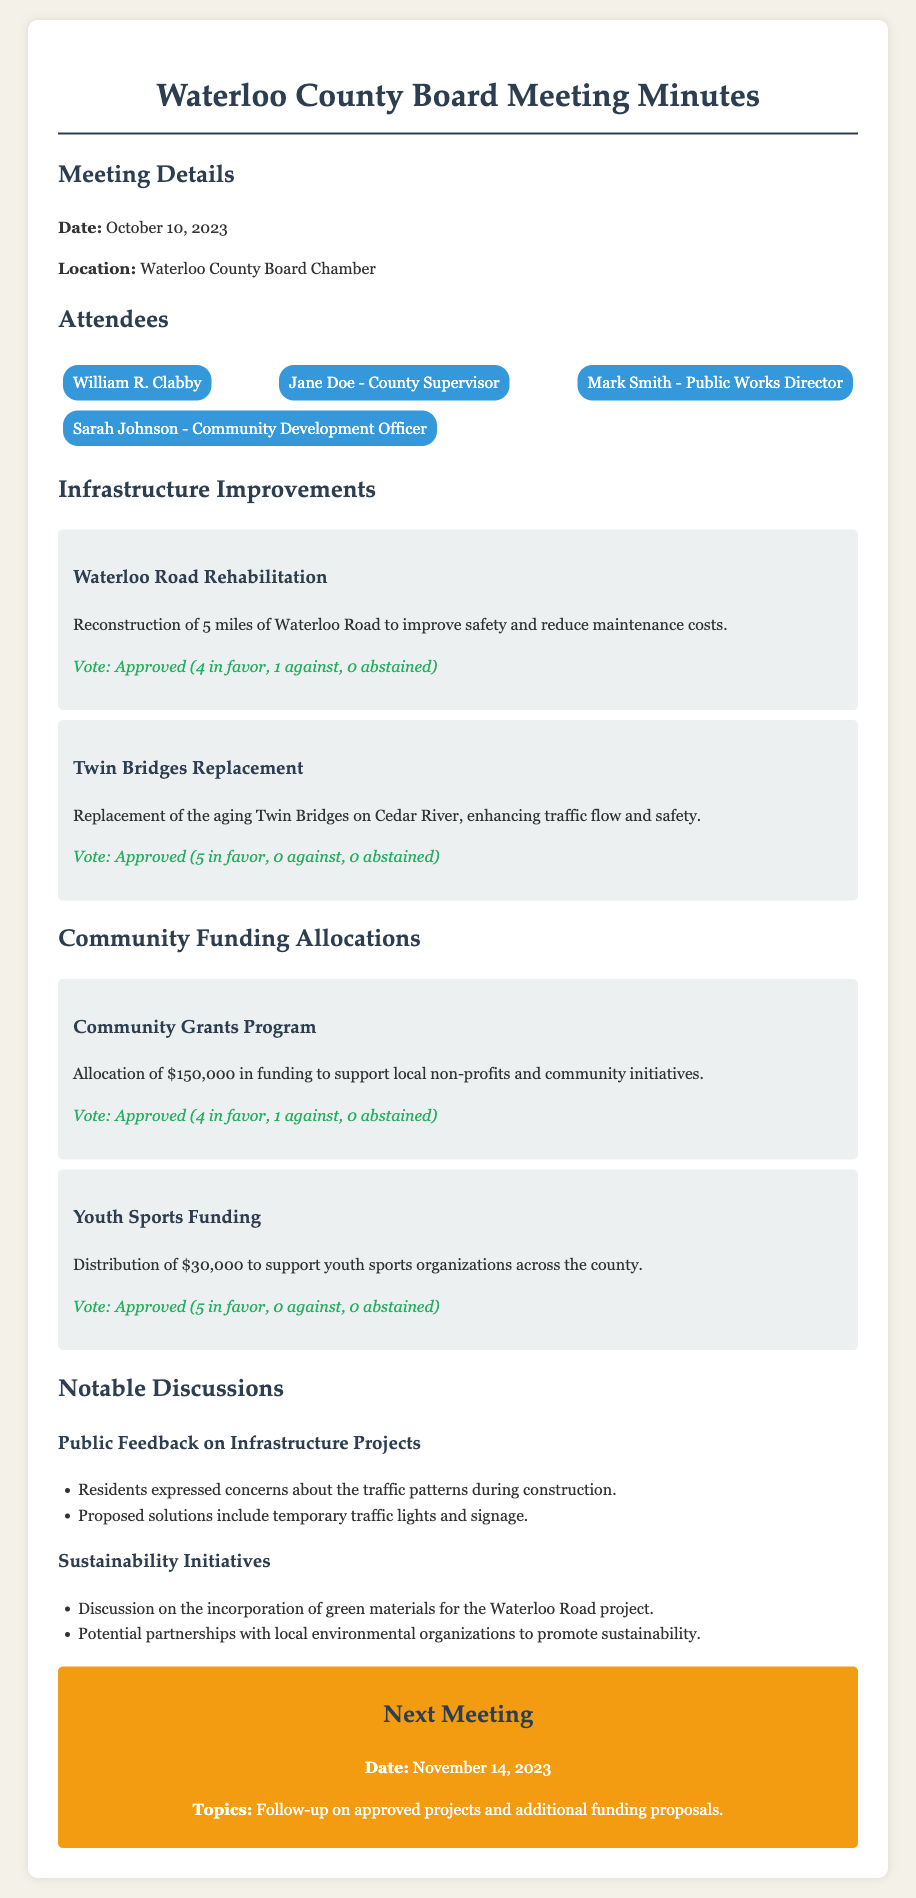What is the date of the meeting? The date of the meeting is clearly stated at the beginning of the minutes.
Answer: October 10, 2023 Who is the Public Works Director? The document lists the attendees, among whom is specified the role of the Public Works Director.
Answer: Mark Smith How many miles of road are being rehabilitated? The project details specify the number of miles included in the Waterloo Road Rehabilitation project.
Answer: 5 miles What is the total funding allocated for the Community Grants Program? The funding amount for the Community Grants Program is explicitly mentioned within the section on community funding allocations.
Answer: $150,000 How many votes were in favor of the Twin Bridges Replacement? The voting results for the Twin Bridges Replacement project indicate the number of votes in favor.
Answer: 5 in favor What was a notable concern raised by residents? The Notable Discussions section notes the concerns expressed by residents regarding construction.
Answer: Traffic patterns How much funding is allocated for Youth Sports? The Youth Sports Funding section provides the distribution amount for supporting youth sports organizations.
Answer: $30,000 When is the next meeting scheduled? The next meeting date is specified under the "Next Meeting" section of the document.
Answer: November 14, 2023 